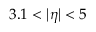Convert formula to latex. <formula><loc_0><loc_0><loc_500><loc_500>3 . 1 < | \eta | < 5</formula> 